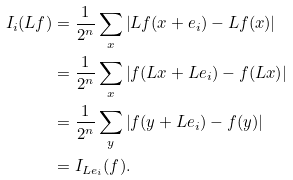<formula> <loc_0><loc_0><loc_500><loc_500>I _ { i } ( L f ) & = \frac { 1 } { 2 ^ { n } } \sum _ { x } \left | L f ( x + e _ { i } ) - L f ( x ) \right | \\ & = \frac { 1 } { 2 ^ { n } } \sum _ { x } \left | f ( L x + L e _ { i } ) - f ( L x ) \right | \\ & = \frac { 1 } { 2 ^ { n } } \sum _ { y } \left | f ( y + L e _ { i } ) - f ( y ) \right | \\ & = I _ { L e _ { i } } ( f ) .</formula> 